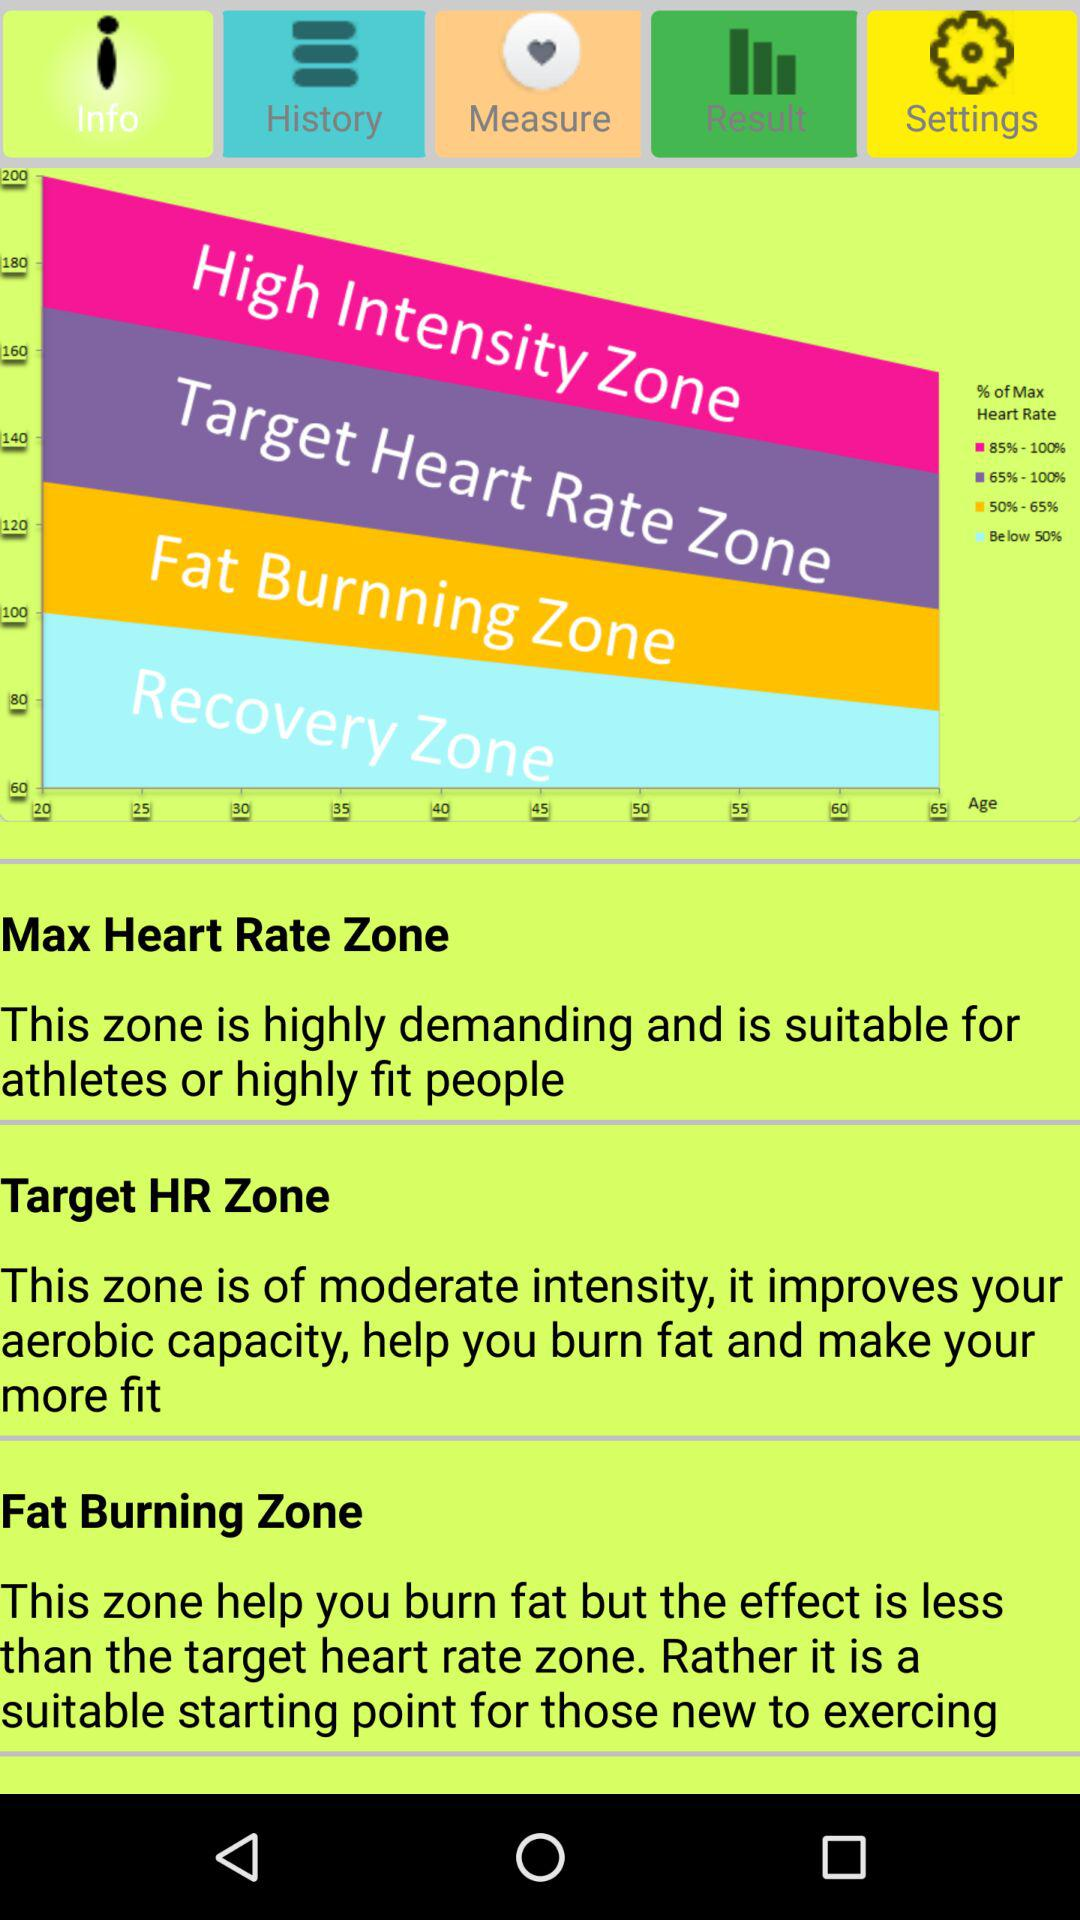Which zone is highly demanding and suitable for athletes? The zone that is highly demanding and suitable for athletes is "Max Heart Rate Zone". 